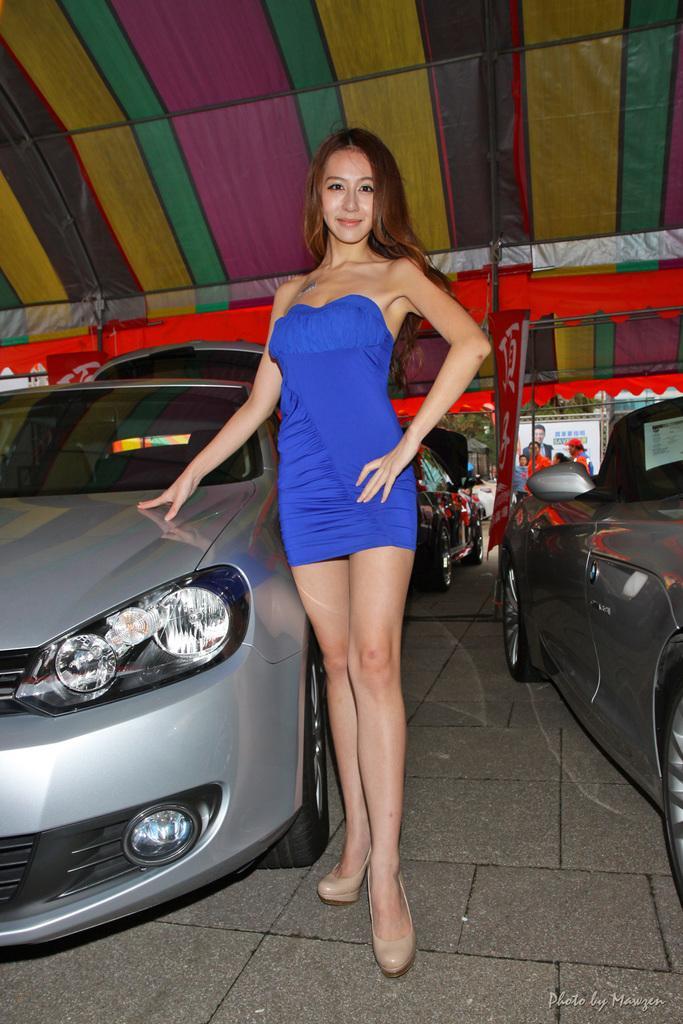Please provide a concise description of this image. In this image we can see there is a woman standing beside the car under the tent also there are so many other cars parked beside. 